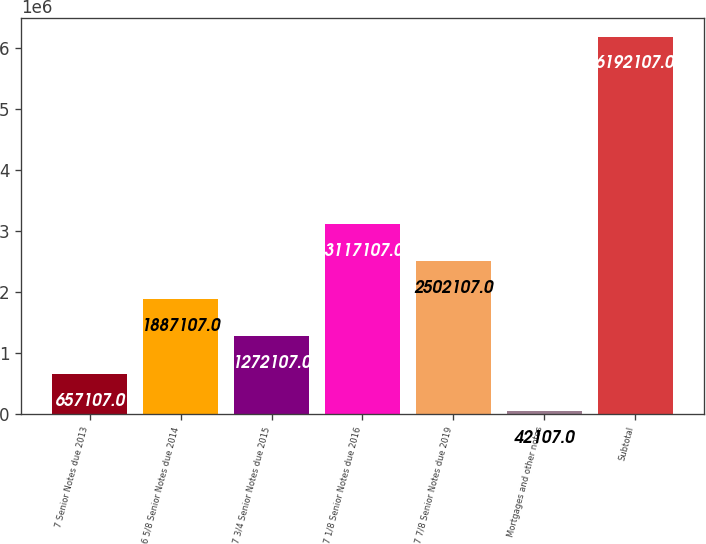<chart> <loc_0><loc_0><loc_500><loc_500><bar_chart><fcel>7 Senior Notes due 2013<fcel>6 5/8 Senior Notes due 2014<fcel>7 3/4 Senior Notes due 2015<fcel>7 1/8 Senior Notes due 2016<fcel>7 7/8 Senior Notes due 2019<fcel>Mortgages and other notes<fcel>Subtotal<nl><fcel>657107<fcel>1.88711e+06<fcel>1.27211e+06<fcel>3.11711e+06<fcel>2.50211e+06<fcel>42107<fcel>6.19211e+06<nl></chart> 